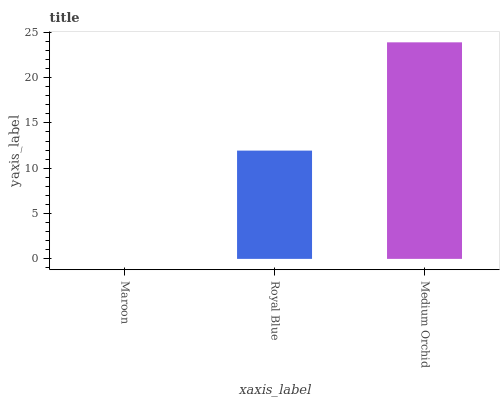Is Royal Blue the minimum?
Answer yes or no. No. Is Royal Blue the maximum?
Answer yes or no. No. Is Royal Blue greater than Maroon?
Answer yes or no. Yes. Is Maroon less than Royal Blue?
Answer yes or no. Yes. Is Maroon greater than Royal Blue?
Answer yes or no. No. Is Royal Blue less than Maroon?
Answer yes or no. No. Is Royal Blue the high median?
Answer yes or no. Yes. Is Royal Blue the low median?
Answer yes or no. Yes. Is Maroon the high median?
Answer yes or no. No. Is Medium Orchid the low median?
Answer yes or no. No. 